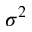Convert formula to latex. <formula><loc_0><loc_0><loc_500><loc_500>\sigma ^ { 2 }</formula> 